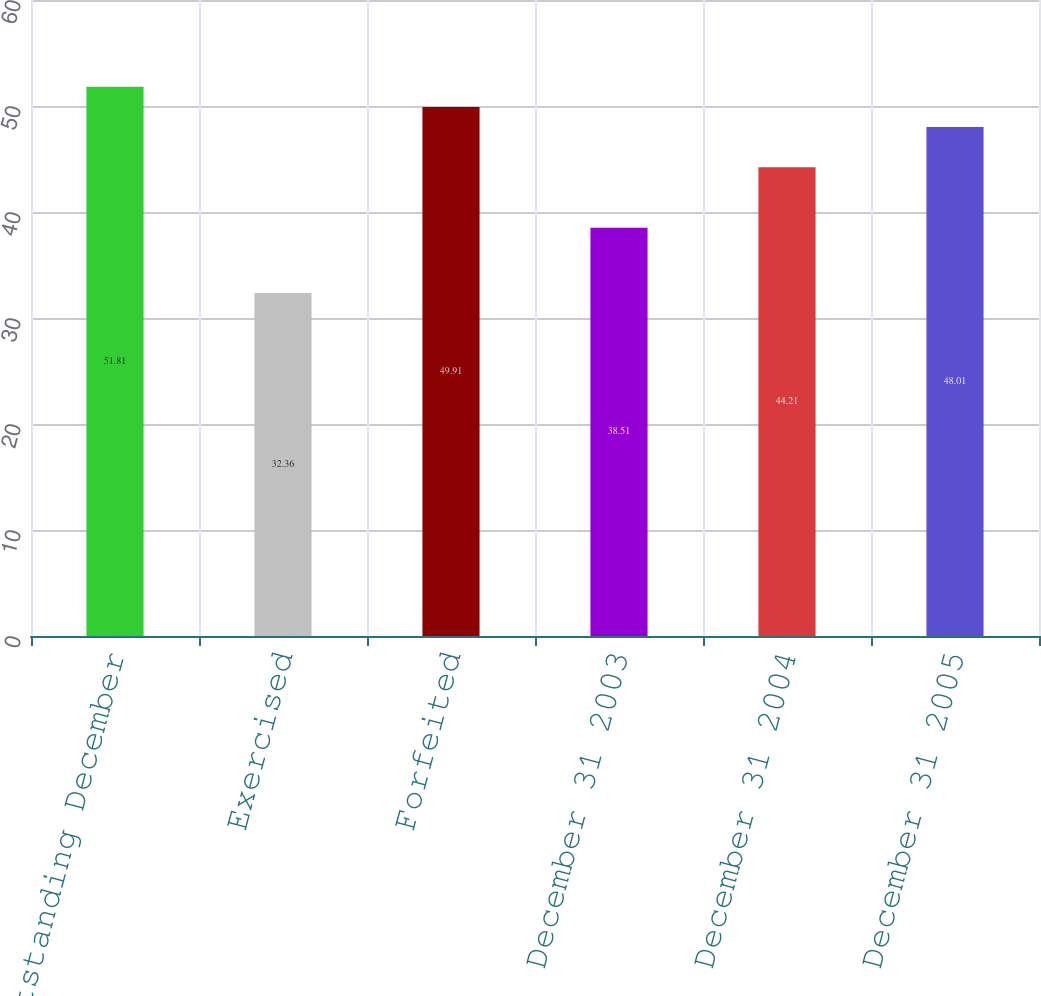Convert chart. <chart><loc_0><loc_0><loc_500><loc_500><bar_chart><fcel>Options Outstanding December<fcel>Exercised<fcel>Forfeited<fcel>December 31 2003<fcel>December 31 2004<fcel>December 31 2005<nl><fcel>51.81<fcel>32.36<fcel>49.91<fcel>38.51<fcel>44.21<fcel>48.01<nl></chart> 